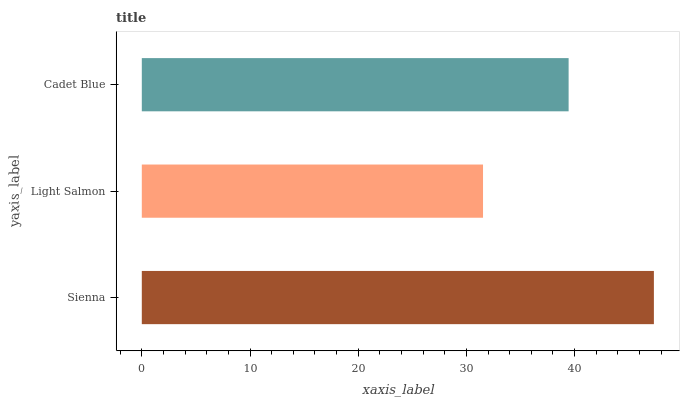Is Light Salmon the minimum?
Answer yes or no. Yes. Is Sienna the maximum?
Answer yes or no. Yes. Is Cadet Blue the minimum?
Answer yes or no. No. Is Cadet Blue the maximum?
Answer yes or no. No. Is Cadet Blue greater than Light Salmon?
Answer yes or no. Yes. Is Light Salmon less than Cadet Blue?
Answer yes or no. Yes. Is Light Salmon greater than Cadet Blue?
Answer yes or no. No. Is Cadet Blue less than Light Salmon?
Answer yes or no. No. Is Cadet Blue the high median?
Answer yes or no. Yes. Is Cadet Blue the low median?
Answer yes or no. Yes. Is Sienna the high median?
Answer yes or no. No. Is Light Salmon the low median?
Answer yes or no. No. 